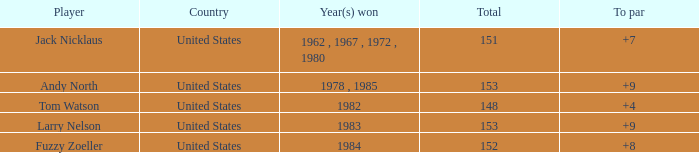What is the To par of the Player wtih Year(s) won of 1983? 9.0. I'm looking to parse the entire table for insights. Could you assist me with that? {'header': ['Player', 'Country', 'Year(s) won', 'Total', 'To par'], 'rows': [['Jack Nicklaus', 'United States', '1962 , 1967 , 1972 , 1980', '151', '+7'], ['Andy North', 'United States', '1978 , 1985', '153', '+9'], ['Tom Watson', 'United States', '1982', '148', '+4'], ['Larry Nelson', 'United States', '1983', '153', '+9'], ['Fuzzy Zoeller', 'United States', '1984', '152', '+8']]} 